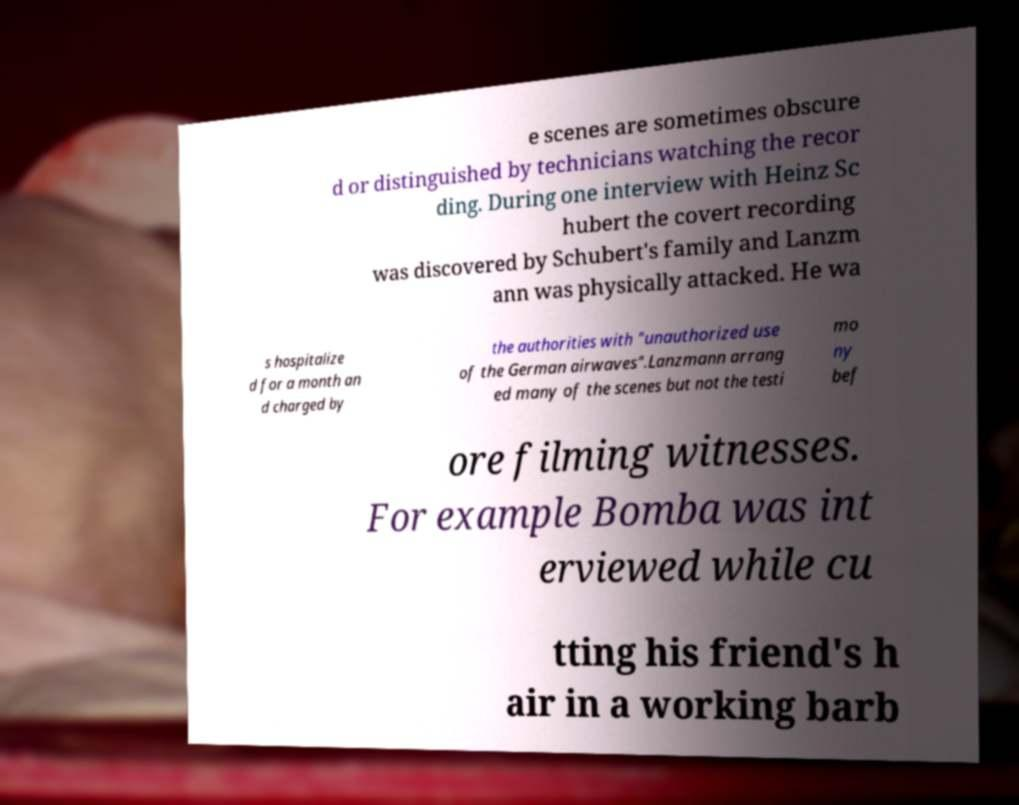There's text embedded in this image that I need extracted. Can you transcribe it verbatim? e scenes are sometimes obscure d or distinguished by technicians watching the recor ding. During one interview with Heinz Sc hubert the covert recording was discovered by Schubert's family and Lanzm ann was physically attacked. He wa s hospitalize d for a month an d charged by the authorities with "unauthorized use of the German airwaves".Lanzmann arrang ed many of the scenes but not the testi mo ny bef ore filming witnesses. For example Bomba was int erviewed while cu tting his friend's h air in a working barb 